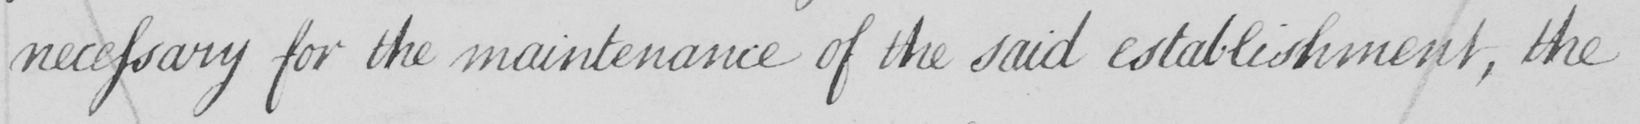Can you tell me what this handwritten text says? necessary for the maintenance of the said establishment , the 